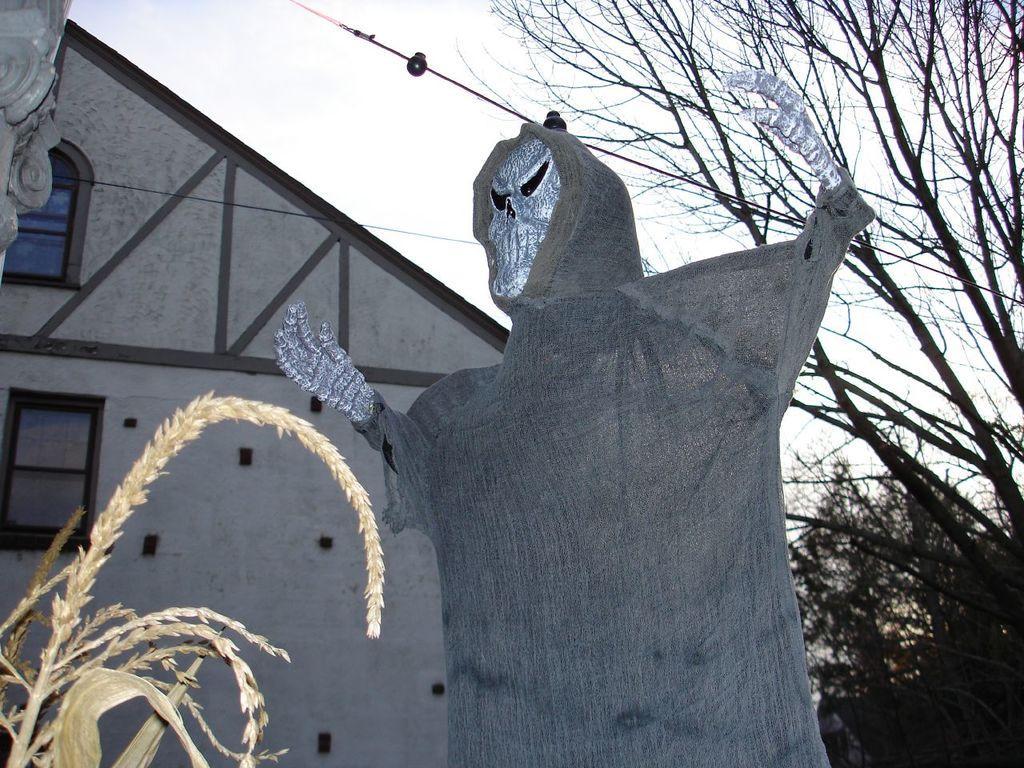Could you give a brief overview of what you see in this image? In this image, we can see a ghost statue. There are a few trees, wires. We can see a house with windows. We can see some plants on the bottom left. We can see the sky. 